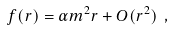<formula> <loc_0><loc_0><loc_500><loc_500>f ( r ) = \alpha m ^ { 2 } r + O ( r ^ { 2 } ) \ ,</formula> 